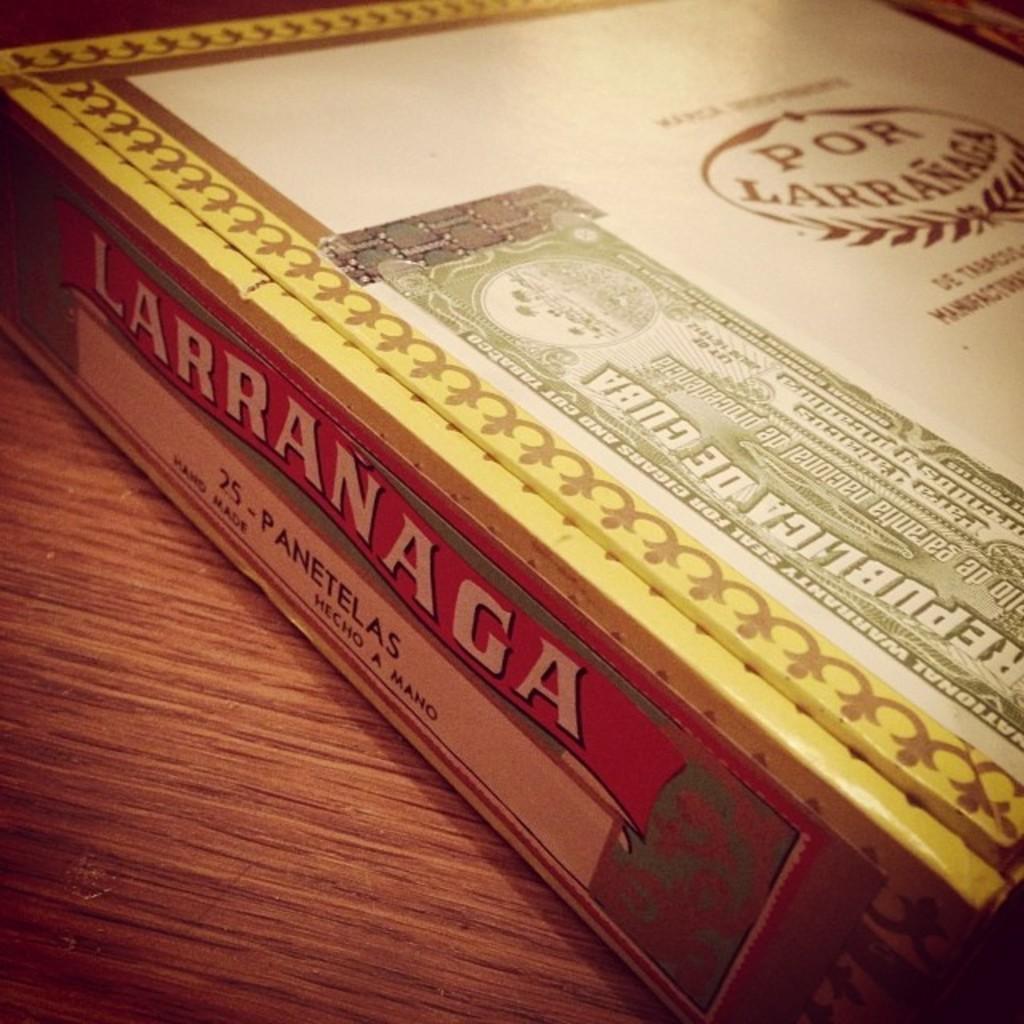What is the title of the book?
Provide a short and direct response. Larranaga. What is the brand name?
Make the answer very short. Larranaga. 